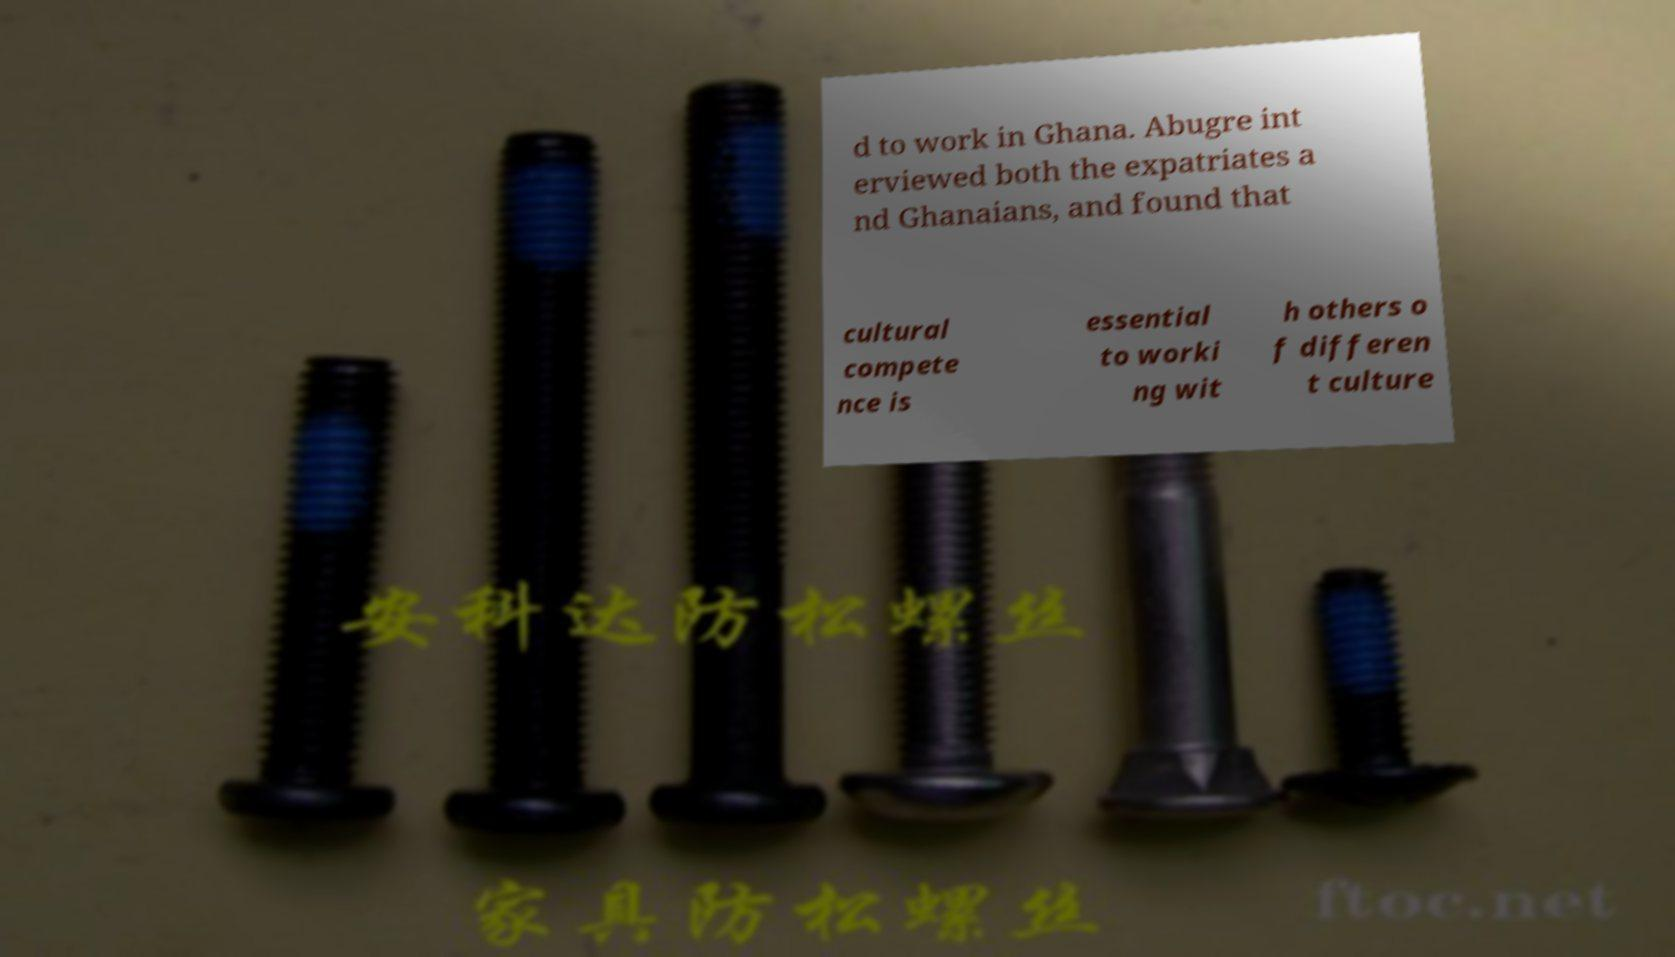I need the written content from this picture converted into text. Can you do that? d to work in Ghana. Abugre int erviewed both the expatriates a nd Ghanaians, and found that cultural compete nce is essential to worki ng wit h others o f differen t culture 